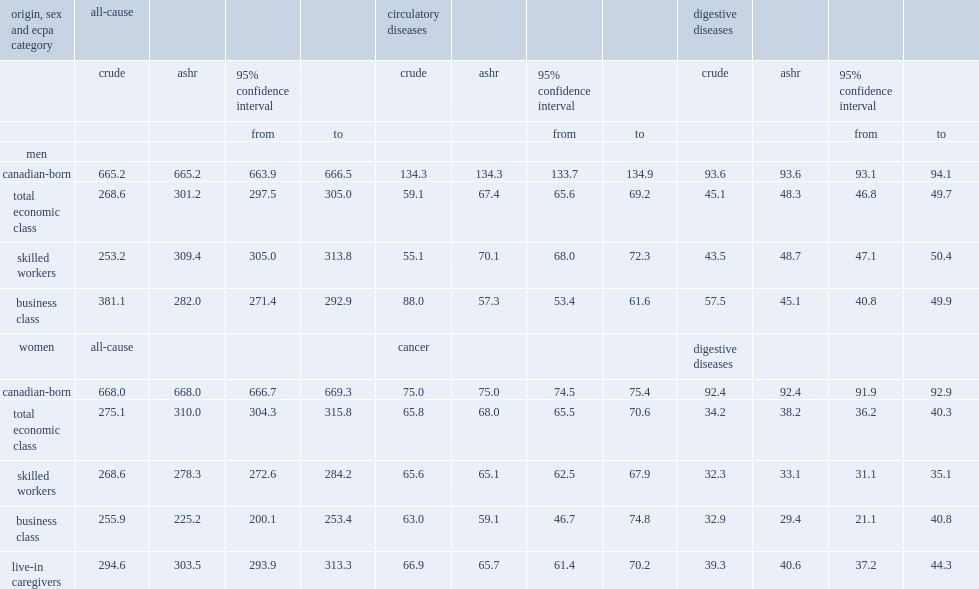What was the number of the all-cause ashr of male ecpas per 10000? 301.2. What was the number of the all-cause ashr of canadian-born men per 10000? 665.2. What was the number of the all-cause ashr of female ecpas per 10000? 310.0. What was the number of the all-cause ashr of canadian-born women per 10000? 668.0. 